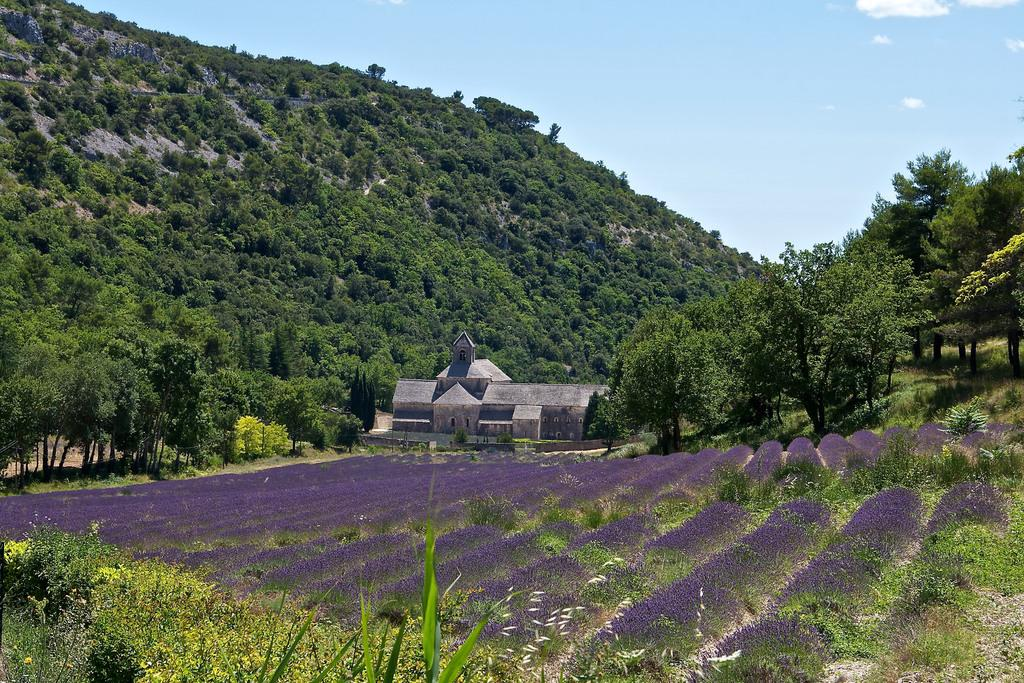What type of structure is visible in the image? There is a building in the image. What other natural elements can be seen in the image? There are trees and plants visible in the image. What is visible at the top of the image? The sky is visible at the top of the image. What can be observed in the sky? There are clouds in the sky. What type of flowers are present at the bottom of the image? Purple color flowers are present at the bottom of the image. Can you describe the stranger walking through the building in the image? There is no stranger present in the image; it only features a building, trees, plants, the sky, clouds, and purple color flowers. What type of rock can be seen near the flowers in the image? There is no rock present near the flowers in the image; it only features purple color flowers at the bottom. 